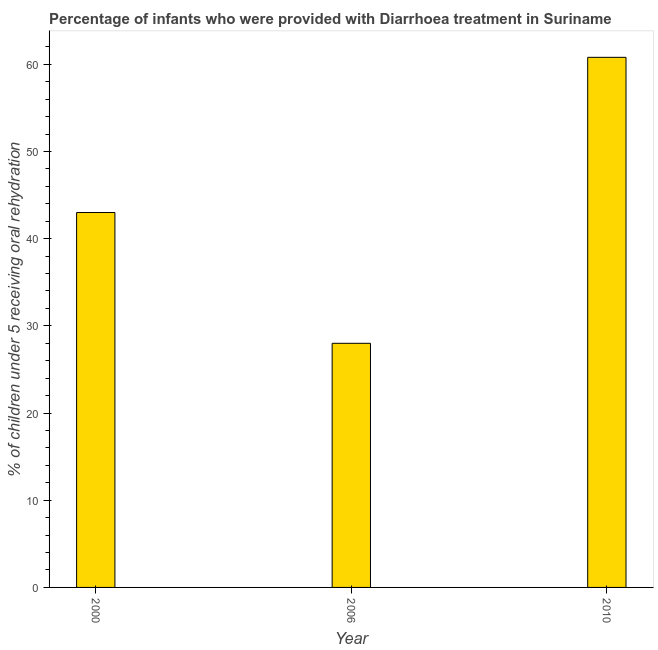Does the graph contain any zero values?
Give a very brief answer. No. What is the title of the graph?
Provide a succinct answer. Percentage of infants who were provided with Diarrhoea treatment in Suriname. What is the label or title of the X-axis?
Make the answer very short. Year. What is the label or title of the Y-axis?
Offer a terse response. % of children under 5 receiving oral rehydration. What is the percentage of children who were provided with treatment diarrhoea in 2000?
Provide a short and direct response. 43. Across all years, what is the maximum percentage of children who were provided with treatment diarrhoea?
Provide a succinct answer. 60.8. In which year was the percentage of children who were provided with treatment diarrhoea maximum?
Ensure brevity in your answer.  2010. What is the sum of the percentage of children who were provided with treatment diarrhoea?
Your response must be concise. 131.8. What is the difference between the percentage of children who were provided with treatment diarrhoea in 2006 and 2010?
Provide a short and direct response. -32.8. What is the average percentage of children who were provided with treatment diarrhoea per year?
Ensure brevity in your answer.  43.93. In how many years, is the percentage of children who were provided with treatment diarrhoea greater than 24 %?
Offer a very short reply. 3. Do a majority of the years between 2000 and 2006 (inclusive) have percentage of children who were provided with treatment diarrhoea greater than 28 %?
Your response must be concise. No. What is the ratio of the percentage of children who were provided with treatment diarrhoea in 2006 to that in 2010?
Your response must be concise. 0.46. Is the percentage of children who were provided with treatment diarrhoea in 2006 less than that in 2010?
Offer a very short reply. Yes. What is the difference between the highest and the second highest percentage of children who were provided with treatment diarrhoea?
Offer a very short reply. 17.8. What is the difference between the highest and the lowest percentage of children who were provided with treatment diarrhoea?
Make the answer very short. 32.8. In how many years, is the percentage of children who were provided with treatment diarrhoea greater than the average percentage of children who were provided with treatment diarrhoea taken over all years?
Provide a short and direct response. 1. How many years are there in the graph?
Make the answer very short. 3. What is the difference between two consecutive major ticks on the Y-axis?
Provide a succinct answer. 10. Are the values on the major ticks of Y-axis written in scientific E-notation?
Keep it short and to the point. No. What is the % of children under 5 receiving oral rehydration in 2006?
Your answer should be compact. 28. What is the % of children under 5 receiving oral rehydration in 2010?
Your response must be concise. 60.8. What is the difference between the % of children under 5 receiving oral rehydration in 2000 and 2010?
Give a very brief answer. -17.8. What is the difference between the % of children under 5 receiving oral rehydration in 2006 and 2010?
Your answer should be very brief. -32.8. What is the ratio of the % of children under 5 receiving oral rehydration in 2000 to that in 2006?
Offer a terse response. 1.54. What is the ratio of the % of children under 5 receiving oral rehydration in 2000 to that in 2010?
Your response must be concise. 0.71. What is the ratio of the % of children under 5 receiving oral rehydration in 2006 to that in 2010?
Provide a short and direct response. 0.46. 